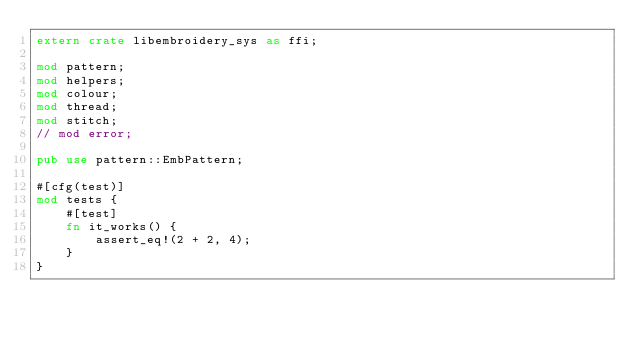<code> <loc_0><loc_0><loc_500><loc_500><_Rust_>extern crate libembroidery_sys as ffi;

mod pattern;
mod helpers;
mod colour;
mod thread;
mod stitch;
// mod error;

pub use pattern::EmbPattern;

#[cfg(test)]
mod tests {
    #[test]
    fn it_works() {
        assert_eq!(2 + 2, 4);
    }
}
</code> 